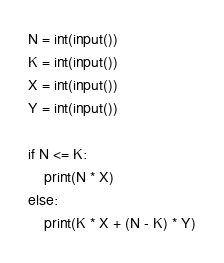Convert code to text. <code><loc_0><loc_0><loc_500><loc_500><_Python_>N = int(input())
K = int(input())
X = int(input())
Y = int(input())

if N <= K:
    print(N * X)
else:
    print(K * X + (N - K) * Y)</code> 